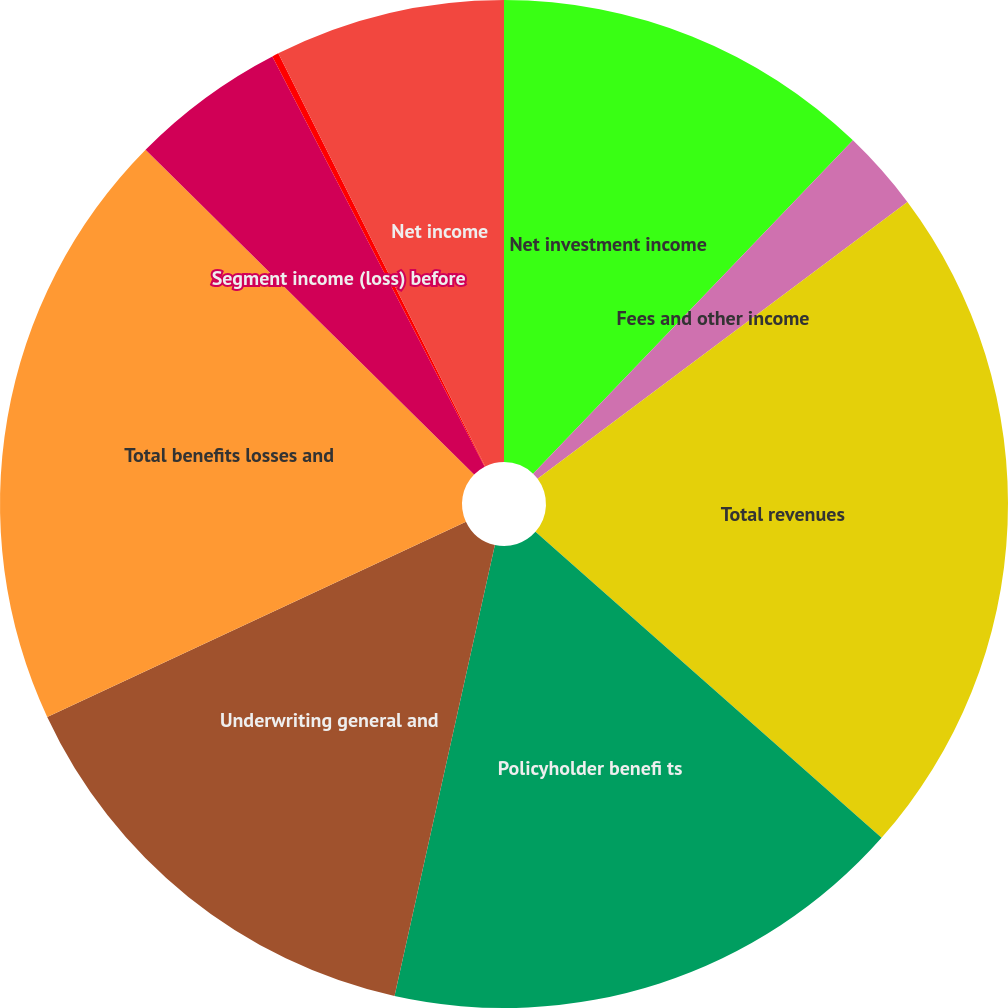<chart> <loc_0><loc_0><loc_500><loc_500><pie_chart><fcel>Net investment income<fcel>Fees and other income<fcel>Total revenues<fcel>Policyholder benefi ts<fcel>Underwriting general and<fcel>Total benefits losses and<fcel>Segment income (loss) before<fcel>Provision (benefit) for income<fcel>Net income<nl><fcel>12.17%<fcel>2.6%<fcel>21.75%<fcel>16.96%<fcel>14.57%<fcel>19.35%<fcel>4.99%<fcel>0.21%<fcel>7.39%<nl></chart> 